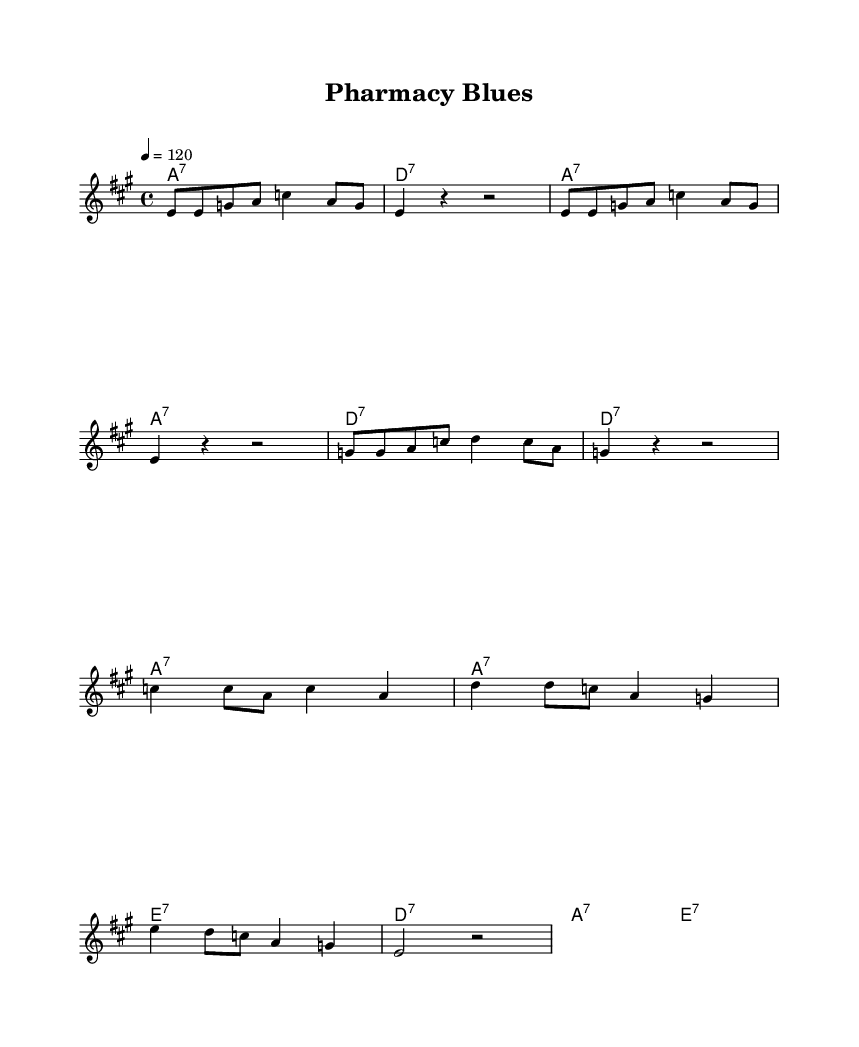What is the key signature of this music? The key signature is A major, which has three sharps: F#, C#, and G#.
Answer: A major What is the time signature of this piece? The time signature is indicated as 4/4, which means there are four beats per measure and the quarter note gets one beat.
Answer: 4/4 What is the tempo marking for this piece? The tempo marking is indicated as 4 = 120, which means there are 120 beats per minute.
Answer: 120 How many measures are in the verse section? The verse section consists of two repeated measures plus an additional four measures, totaling six measures in this section.
Answer: 6 In the chorus, how many lines of lyrics are there? There are four lines of lyrics in the chorus section, each corresponding to the repeated chord progression.
Answer: 4 What type of seventh chord is used in the harmonies? The harmonies use dominant seventh chords, specifically noted as A7, D7, and E7 according to the chord notation.
Answer: Dominant seventh chords Which health concept does the song emphasize in the lyrics? The lyrics emphasize maintaining a healthy lifestyle through visits to the local pharmacy and taking vitamins, celebrating wellness.
Answer: Healthy lifestyle 